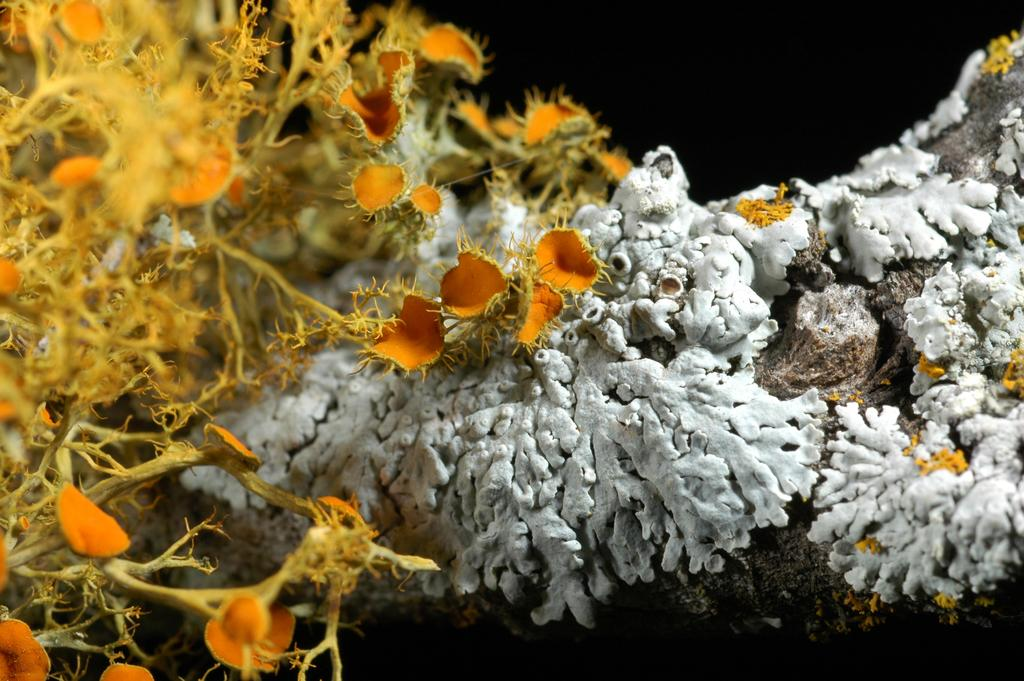What type of plants are visible in the image? There are underwater plants in the image. What colors are the underwater plants? The underwater plants are in yellow and white colors. What type of verse or rhythm can be heard from the bells in the image? There are no bells present in the image, so there is no verse or rhythm to be heard. 